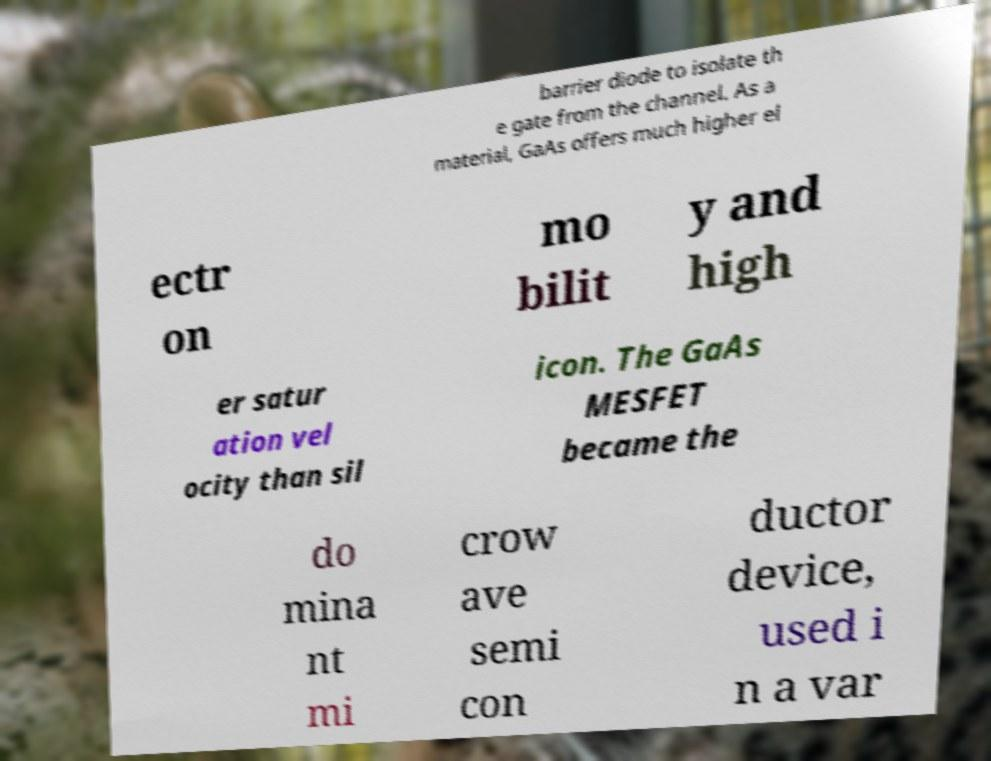Could you assist in decoding the text presented in this image and type it out clearly? barrier diode to isolate th e gate from the channel. As a material, GaAs offers much higher el ectr on mo bilit y and high er satur ation vel ocity than sil icon. The GaAs MESFET became the do mina nt mi crow ave semi con ductor device, used i n a var 